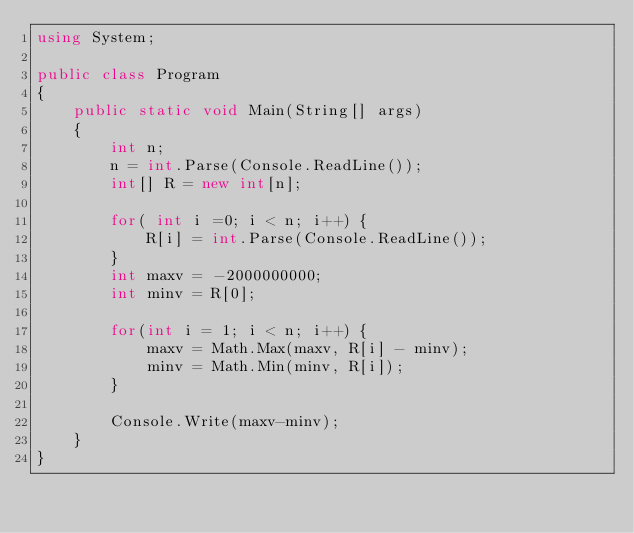<code> <loc_0><loc_0><loc_500><loc_500><_C#_>using System;                                                                   

public class Program
{
    public static void Main(String[] args)
    {
        int n;
        n = int.Parse(Console.ReadLine());
        int[] R = new int[n];

        for( int i =0; i < n; i++) {
            R[i] = int.Parse(Console.ReadLine());
        }
        int maxv = -2000000000;
        int minv = R[0];

        for(int i = 1; i < n; i++) {
            maxv = Math.Max(maxv, R[i] - minv);
            minv = Math.Min(minv, R[i]);
        }

        Console.Write(maxv-minv);
    }
}</code> 